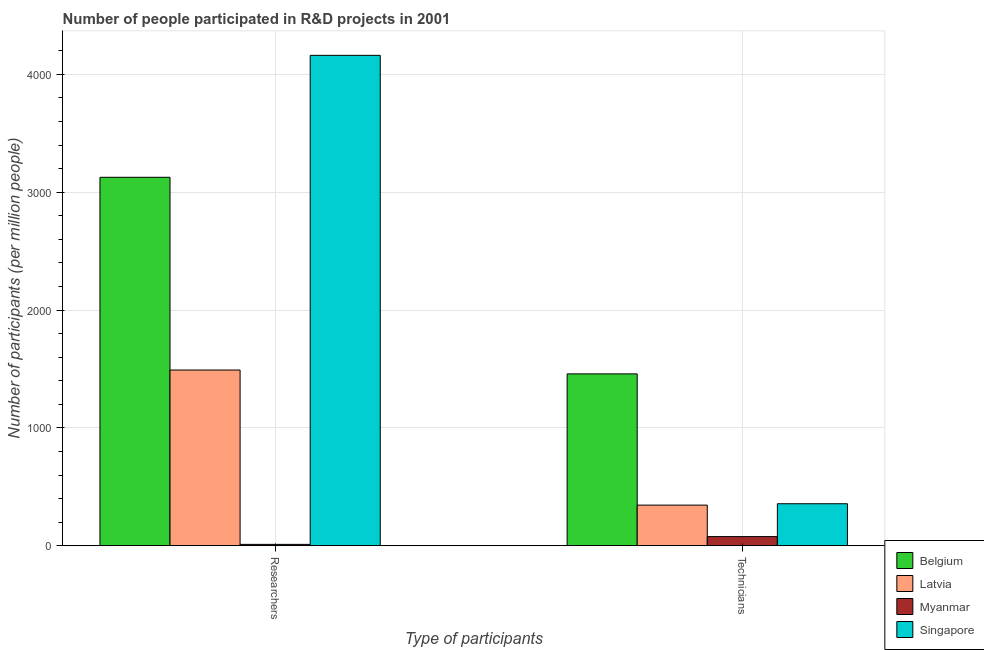How many groups of bars are there?
Offer a terse response. 2. Are the number of bars on each tick of the X-axis equal?
Give a very brief answer. Yes. How many bars are there on the 2nd tick from the left?
Ensure brevity in your answer.  4. What is the label of the 2nd group of bars from the left?
Ensure brevity in your answer.  Technicians. What is the number of technicians in Belgium?
Your answer should be compact. 1458.35. Across all countries, what is the maximum number of technicians?
Offer a terse response. 1458.35. Across all countries, what is the minimum number of technicians?
Keep it short and to the point. 77.87. In which country was the number of researchers maximum?
Provide a succinct answer. Singapore. In which country was the number of researchers minimum?
Ensure brevity in your answer.  Myanmar. What is the total number of technicians in the graph?
Your response must be concise. 2237.82. What is the difference between the number of researchers in Belgium and that in Singapore?
Your answer should be very brief. -1034.61. What is the difference between the number of researchers in Belgium and the number of technicians in Myanmar?
Make the answer very short. 3048.45. What is the average number of researchers per country?
Provide a succinct answer. 2197.58. What is the difference between the number of technicians and number of researchers in Latvia?
Your answer should be very brief. -1146.2. In how many countries, is the number of researchers greater than 2600 ?
Make the answer very short. 2. What is the ratio of the number of technicians in Latvia to that in Singapore?
Offer a terse response. 0.97. Is the number of researchers in Myanmar less than that in Singapore?
Make the answer very short. Yes. What does the 2nd bar from the left in Researchers represents?
Your answer should be compact. Latvia. How many bars are there?
Offer a very short reply. 8. Are the values on the major ticks of Y-axis written in scientific E-notation?
Your response must be concise. No. Does the graph contain grids?
Your response must be concise. Yes. How are the legend labels stacked?
Your answer should be very brief. Vertical. What is the title of the graph?
Keep it short and to the point. Number of people participated in R&D projects in 2001. Does "Vietnam" appear as one of the legend labels in the graph?
Ensure brevity in your answer.  No. What is the label or title of the X-axis?
Ensure brevity in your answer.  Type of participants. What is the label or title of the Y-axis?
Keep it short and to the point. Number of participants (per million people). What is the Number of participants (per million people) of Belgium in Researchers?
Provide a short and direct response. 3126.32. What is the Number of participants (per million people) of Latvia in Researchers?
Provide a succinct answer. 1491.17. What is the Number of participants (per million people) of Myanmar in Researchers?
Give a very brief answer. 11.91. What is the Number of participants (per million people) of Singapore in Researchers?
Your answer should be very brief. 4160.93. What is the Number of participants (per million people) in Belgium in Technicians?
Your answer should be very brief. 1458.35. What is the Number of participants (per million people) in Latvia in Technicians?
Offer a terse response. 344.97. What is the Number of participants (per million people) in Myanmar in Technicians?
Give a very brief answer. 77.87. What is the Number of participants (per million people) in Singapore in Technicians?
Ensure brevity in your answer.  356.63. Across all Type of participants, what is the maximum Number of participants (per million people) of Belgium?
Give a very brief answer. 3126.32. Across all Type of participants, what is the maximum Number of participants (per million people) of Latvia?
Provide a short and direct response. 1491.17. Across all Type of participants, what is the maximum Number of participants (per million people) of Myanmar?
Give a very brief answer. 77.87. Across all Type of participants, what is the maximum Number of participants (per million people) in Singapore?
Provide a short and direct response. 4160.93. Across all Type of participants, what is the minimum Number of participants (per million people) in Belgium?
Offer a terse response. 1458.35. Across all Type of participants, what is the minimum Number of participants (per million people) in Latvia?
Offer a very short reply. 344.97. Across all Type of participants, what is the minimum Number of participants (per million people) in Myanmar?
Your response must be concise. 11.91. Across all Type of participants, what is the minimum Number of participants (per million people) in Singapore?
Ensure brevity in your answer.  356.63. What is the total Number of participants (per million people) of Belgium in the graph?
Make the answer very short. 4584.67. What is the total Number of participants (per million people) of Latvia in the graph?
Provide a short and direct response. 1836.13. What is the total Number of participants (per million people) in Myanmar in the graph?
Your answer should be compact. 89.78. What is the total Number of participants (per million people) in Singapore in the graph?
Give a very brief answer. 4517.56. What is the difference between the Number of participants (per million people) of Belgium in Researchers and that in Technicians?
Offer a terse response. 1667.97. What is the difference between the Number of participants (per million people) in Latvia in Researchers and that in Technicians?
Your answer should be compact. 1146.2. What is the difference between the Number of participants (per million people) of Myanmar in Researchers and that in Technicians?
Offer a terse response. -65.96. What is the difference between the Number of participants (per million people) of Singapore in Researchers and that in Technicians?
Ensure brevity in your answer.  3804.3. What is the difference between the Number of participants (per million people) of Belgium in Researchers and the Number of participants (per million people) of Latvia in Technicians?
Provide a short and direct response. 2781.35. What is the difference between the Number of participants (per million people) of Belgium in Researchers and the Number of participants (per million people) of Myanmar in Technicians?
Your response must be concise. 3048.45. What is the difference between the Number of participants (per million people) in Belgium in Researchers and the Number of participants (per million people) in Singapore in Technicians?
Provide a succinct answer. 2769.69. What is the difference between the Number of participants (per million people) in Latvia in Researchers and the Number of participants (per million people) in Myanmar in Technicians?
Your answer should be very brief. 1413.3. What is the difference between the Number of participants (per million people) in Latvia in Researchers and the Number of participants (per million people) in Singapore in Technicians?
Your answer should be compact. 1134.54. What is the difference between the Number of participants (per million people) of Myanmar in Researchers and the Number of participants (per million people) of Singapore in Technicians?
Your answer should be compact. -344.72. What is the average Number of participants (per million people) in Belgium per Type of participants?
Ensure brevity in your answer.  2292.33. What is the average Number of participants (per million people) in Latvia per Type of participants?
Provide a short and direct response. 918.07. What is the average Number of participants (per million people) in Myanmar per Type of participants?
Ensure brevity in your answer.  44.89. What is the average Number of participants (per million people) in Singapore per Type of participants?
Ensure brevity in your answer.  2258.78. What is the difference between the Number of participants (per million people) of Belgium and Number of participants (per million people) of Latvia in Researchers?
Your answer should be compact. 1635.15. What is the difference between the Number of participants (per million people) in Belgium and Number of participants (per million people) in Myanmar in Researchers?
Keep it short and to the point. 3114.41. What is the difference between the Number of participants (per million people) of Belgium and Number of participants (per million people) of Singapore in Researchers?
Give a very brief answer. -1034.61. What is the difference between the Number of participants (per million people) of Latvia and Number of participants (per million people) of Myanmar in Researchers?
Offer a terse response. 1479.26. What is the difference between the Number of participants (per million people) of Latvia and Number of participants (per million people) of Singapore in Researchers?
Ensure brevity in your answer.  -2669.77. What is the difference between the Number of participants (per million people) of Myanmar and Number of participants (per million people) of Singapore in Researchers?
Your answer should be compact. -4149.02. What is the difference between the Number of participants (per million people) of Belgium and Number of participants (per million people) of Latvia in Technicians?
Give a very brief answer. 1113.38. What is the difference between the Number of participants (per million people) in Belgium and Number of participants (per million people) in Myanmar in Technicians?
Your answer should be compact. 1380.48. What is the difference between the Number of participants (per million people) of Belgium and Number of participants (per million people) of Singapore in Technicians?
Give a very brief answer. 1101.72. What is the difference between the Number of participants (per million people) in Latvia and Number of participants (per million people) in Myanmar in Technicians?
Give a very brief answer. 267.1. What is the difference between the Number of participants (per million people) of Latvia and Number of participants (per million people) of Singapore in Technicians?
Provide a short and direct response. -11.66. What is the difference between the Number of participants (per million people) in Myanmar and Number of participants (per million people) in Singapore in Technicians?
Make the answer very short. -278.76. What is the ratio of the Number of participants (per million people) of Belgium in Researchers to that in Technicians?
Ensure brevity in your answer.  2.14. What is the ratio of the Number of participants (per million people) in Latvia in Researchers to that in Technicians?
Offer a very short reply. 4.32. What is the ratio of the Number of participants (per million people) of Myanmar in Researchers to that in Technicians?
Your answer should be compact. 0.15. What is the ratio of the Number of participants (per million people) in Singapore in Researchers to that in Technicians?
Provide a succinct answer. 11.67. What is the difference between the highest and the second highest Number of participants (per million people) of Belgium?
Keep it short and to the point. 1667.97. What is the difference between the highest and the second highest Number of participants (per million people) of Latvia?
Your response must be concise. 1146.2. What is the difference between the highest and the second highest Number of participants (per million people) of Myanmar?
Provide a succinct answer. 65.96. What is the difference between the highest and the second highest Number of participants (per million people) of Singapore?
Offer a very short reply. 3804.3. What is the difference between the highest and the lowest Number of participants (per million people) in Belgium?
Your response must be concise. 1667.97. What is the difference between the highest and the lowest Number of participants (per million people) of Latvia?
Your response must be concise. 1146.2. What is the difference between the highest and the lowest Number of participants (per million people) in Myanmar?
Provide a succinct answer. 65.96. What is the difference between the highest and the lowest Number of participants (per million people) of Singapore?
Your response must be concise. 3804.3. 